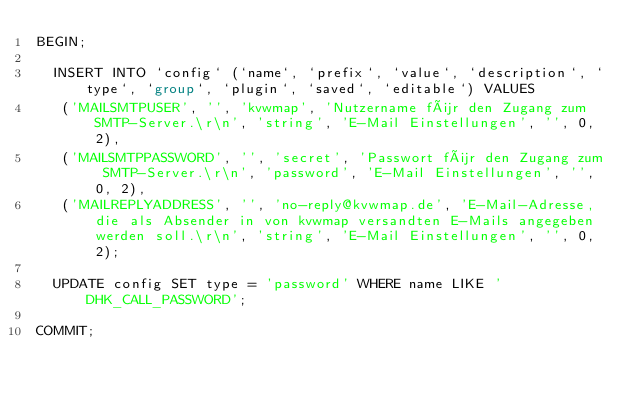<code> <loc_0><loc_0><loc_500><loc_500><_SQL_>BEGIN;

  INSERT INTO `config` (`name`, `prefix`, `value`, `description`, `type`, `group`, `plugin`, `saved`, `editable`) VALUES
   ('MAILSMTPUSER', '', 'kvwmap', 'Nutzername für den Zugang zum SMTP-Server.\r\n', 'string', 'E-Mail Einstellungen', '', 0, 2),
   ('MAILSMTPPASSWORD', '', 'secret', 'Passwort für den Zugang zum SMTP-Server.\r\n', 'password', 'E-Mail Einstellungen', '', 0, 2),
   ('MAILREPLYADDRESS', '', 'no-reply@kvwmap.de', 'E-Mail-Adresse, die als Absender in von kvwmap versandten E-Mails angegeben werden soll.\r\n', 'string', 'E-Mail Einstellungen', '', 0, 2);

  UPDATE config SET type = 'password' WHERE name LIKE 'DHK_CALL_PASSWORD';

COMMIT;
</code> 